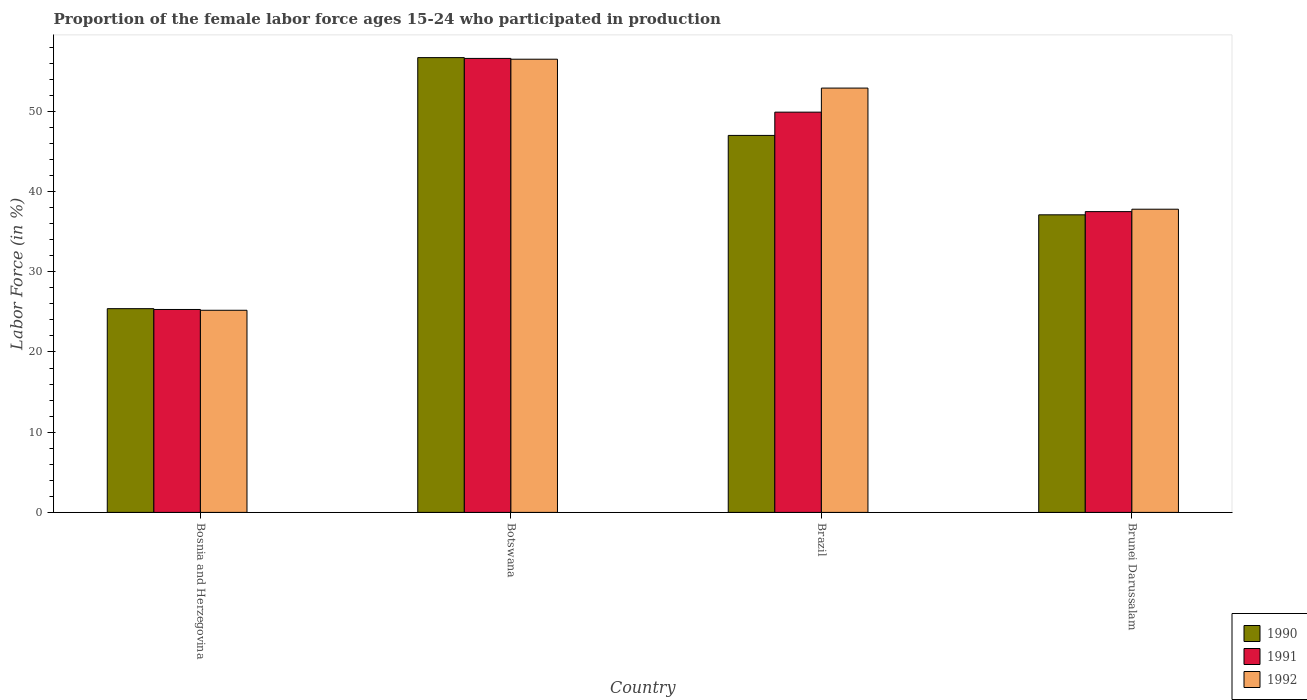How many different coloured bars are there?
Give a very brief answer. 3. How many groups of bars are there?
Keep it short and to the point. 4. Are the number of bars per tick equal to the number of legend labels?
Your answer should be very brief. Yes. Are the number of bars on each tick of the X-axis equal?
Offer a very short reply. Yes. How many bars are there on the 4th tick from the left?
Your answer should be very brief. 3. What is the label of the 1st group of bars from the left?
Keep it short and to the point. Bosnia and Herzegovina. What is the proportion of the female labor force who participated in production in 1990 in Brunei Darussalam?
Provide a short and direct response. 37.1. Across all countries, what is the maximum proportion of the female labor force who participated in production in 1992?
Provide a short and direct response. 56.5. Across all countries, what is the minimum proportion of the female labor force who participated in production in 1990?
Keep it short and to the point. 25.4. In which country was the proportion of the female labor force who participated in production in 1992 maximum?
Offer a very short reply. Botswana. In which country was the proportion of the female labor force who participated in production in 1992 minimum?
Give a very brief answer. Bosnia and Herzegovina. What is the total proportion of the female labor force who participated in production in 1990 in the graph?
Keep it short and to the point. 166.2. What is the difference between the proportion of the female labor force who participated in production in 1990 in Bosnia and Herzegovina and that in Brazil?
Provide a succinct answer. -21.6. What is the difference between the proportion of the female labor force who participated in production in 1991 in Bosnia and Herzegovina and the proportion of the female labor force who participated in production in 1992 in Brazil?
Your response must be concise. -27.6. What is the average proportion of the female labor force who participated in production in 1991 per country?
Ensure brevity in your answer.  42.32. What is the difference between the proportion of the female labor force who participated in production of/in 1990 and proportion of the female labor force who participated in production of/in 1992 in Bosnia and Herzegovina?
Offer a very short reply. 0.2. What is the ratio of the proportion of the female labor force who participated in production in 1990 in Brazil to that in Brunei Darussalam?
Offer a terse response. 1.27. Is the difference between the proportion of the female labor force who participated in production in 1990 in Botswana and Brunei Darussalam greater than the difference between the proportion of the female labor force who participated in production in 1992 in Botswana and Brunei Darussalam?
Your answer should be very brief. Yes. What is the difference between the highest and the second highest proportion of the female labor force who participated in production in 1992?
Offer a terse response. 3.6. What is the difference between the highest and the lowest proportion of the female labor force who participated in production in 1992?
Your answer should be compact. 31.3. What does the 2nd bar from the left in Bosnia and Herzegovina represents?
Ensure brevity in your answer.  1991. What does the 3rd bar from the right in Brazil represents?
Offer a very short reply. 1990. Are all the bars in the graph horizontal?
Give a very brief answer. No. How many countries are there in the graph?
Keep it short and to the point. 4. Does the graph contain any zero values?
Keep it short and to the point. No. How many legend labels are there?
Provide a short and direct response. 3. How are the legend labels stacked?
Provide a succinct answer. Vertical. What is the title of the graph?
Offer a very short reply. Proportion of the female labor force ages 15-24 who participated in production. Does "1991" appear as one of the legend labels in the graph?
Provide a short and direct response. Yes. What is the label or title of the Y-axis?
Keep it short and to the point. Labor Force (in %). What is the Labor Force (in %) in 1990 in Bosnia and Herzegovina?
Offer a terse response. 25.4. What is the Labor Force (in %) of 1991 in Bosnia and Herzegovina?
Give a very brief answer. 25.3. What is the Labor Force (in %) in 1992 in Bosnia and Herzegovina?
Your answer should be very brief. 25.2. What is the Labor Force (in %) of 1990 in Botswana?
Provide a succinct answer. 56.7. What is the Labor Force (in %) of 1991 in Botswana?
Offer a very short reply. 56.6. What is the Labor Force (in %) in 1992 in Botswana?
Keep it short and to the point. 56.5. What is the Labor Force (in %) of 1990 in Brazil?
Give a very brief answer. 47. What is the Labor Force (in %) in 1991 in Brazil?
Your answer should be very brief. 49.9. What is the Labor Force (in %) of 1992 in Brazil?
Give a very brief answer. 52.9. What is the Labor Force (in %) in 1990 in Brunei Darussalam?
Your response must be concise. 37.1. What is the Labor Force (in %) of 1991 in Brunei Darussalam?
Keep it short and to the point. 37.5. What is the Labor Force (in %) in 1992 in Brunei Darussalam?
Offer a very short reply. 37.8. Across all countries, what is the maximum Labor Force (in %) in 1990?
Provide a short and direct response. 56.7. Across all countries, what is the maximum Labor Force (in %) of 1991?
Give a very brief answer. 56.6. Across all countries, what is the maximum Labor Force (in %) in 1992?
Your response must be concise. 56.5. Across all countries, what is the minimum Labor Force (in %) of 1990?
Give a very brief answer. 25.4. Across all countries, what is the minimum Labor Force (in %) in 1991?
Provide a succinct answer. 25.3. Across all countries, what is the minimum Labor Force (in %) of 1992?
Your answer should be very brief. 25.2. What is the total Labor Force (in %) in 1990 in the graph?
Your answer should be very brief. 166.2. What is the total Labor Force (in %) in 1991 in the graph?
Your answer should be compact. 169.3. What is the total Labor Force (in %) of 1992 in the graph?
Your answer should be very brief. 172.4. What is the difference between the Labor Force (in %) of 1990 in Bosnia and Herzegovina and that in Botswana?
Offer a terse response. -31.3. What is the difference between the Labor Force (in %) of 1991 in Bosnia and Herzegovina and that in Botswana?
Ensure brevity in your answer.  -31.3. What is the difference between the Labor Force (in %) in 1992 in Bosnia and Herzegovina and that in Botswana?
Provide a short and direct response. -31.3. What is the difference between the Labor Force (in %) of 1990 in Bosnia and Herzegovina and that in Brazil?
Your answer should be compact. -21.6. What is the difference between the Labor Force (in %) of 1991 in Bosnia and Herzegovina and that in Brazil?
Your response must be concise. -24.6. What is the difference between the Labor Force (in %) of 1992 in Bosnia and Herzegovina and that in Brazil?
Make the answer very short. -27.7. What is the difference between the Labor Force (in %) of 1990 in Botswana and that in Brazil?
Your answer should be very brief. 9.7. What is the difference between the Labor Force (in %) of 1992 in Botswana and that in Brazil?
Ensure brevity in your answer.  3.6. What is the difference between the Labor Force (in %) in 1990 in Botswana and that in Brunei Darussalam?
Provide a short and direct response. 19.6. What is the difference between the Labor Force (in %) in 1991 in Botswana and that in Brunei Darussalam?
Keep it short and to the point. 19.1. What is the difference between the Labor Force (in %) in 1990 in Brazil and that in Brunei Darussalam?
Make the answer very short. 9.9. What is the difference between the Labor Force (in %) of 1991 in Brazil and that in Brunei Darussalam?
Provide a succinct answer. 12.4. What is the difference between the Labor Force (in %) in 1992 in Brazil and that in Brunei Darussalam?
Ensure brevity in your answer.  15.1. What is the difference between the Labor Force (in %) in 1990 in Bosnia and Herzegovina and the Labor Force (in %) in 1991 in Botswana?
Give a very brief answer. -31.2. What is the difference between the Labor Force (in %) in 1990 in Bosnia and Herzegovina and the Labor Force (in %) in 1992 in Botswana?
Ensure brevity in your answer.  -31.1. What is the difference between the Labor Force (in %) of 1991 in Bosnia and Herzegovina and the Labor Force (in %) of 1992 in Botswana?
Offer a very short reply. -31.2. What is the difference between the Labor Force (in %) of 1990 in Bosnia and Herzegovina and the Labor Force (in %) of 1991 in Brazil?
Make the answer very short. -24.5. What is the difference between the Labor Force (in %) of 1990 in Bosnia and Herzegovina and the Labor Force (in %) of 1992 in Brazil?
Your answer should be very brief. -27.5. What is the difference between the Labor Force (in %) of 1991 in Bosnia and Herzegovina and the Labor Force (in %) of 1992 in Brazil?
Make the answer very short. -27.6. What is the difference between the Labor Force (in %) of 1990 in Bosnia and Herzegovina and the Labor Force (in %) of 1991 in Brunei Darussalam?
Your answer should be very brief. -12.1. What is the difference between the Labor Force (in %) of 1990 in Bosnia and Herzegovina and the Labor Force (in %) of 1992 in Brunei Darussalam?
Offer a terse response. -12.4. What is the difference between the Labor Force (in %) in 1991 in Bosnia and Herzegovina and the Labor Force (in %) in 1992 in Brunei Darussalam?
Ensure brevity in your answer.  -12.5. What is the difference between the Labor Force (in %) of 1990 in Botswana and the Labor Force (in %) of 1991 in Brazil?
Offer a very short reply. 6.8. What is the difference between the Labor Force (in %) in 1990 in Botswana and the Labor Force (in %) in 1991 in Brunei Darussalam?
Offer a very short reply. 19.2. What is the difference between the Labor Force (in %) of 1991 in Botswana and the Labor Force (in %) of 1992 in Brunei Darussalam?
Provide a succinct answer. 18.8. What is the difference between the Labor Force (in %) of 1990 in Brazil and the Labor Force (in %) of 1991 in Brunei Darussalam?
Your response must be concise. 9.5. What is the average Labor Force (in %) of 1990 per country?
Provide a short and direct response. 41.55. What is the average Labor Force (in %) in 1991 per country?
Provide a short and direct response. 42.33. What is the average Labor Force (in %) of 1992 per country?
Keep it short and to the point. 43.1. What is the difference between the Labor Force (in %) in 1990 and Labor Force (in %) in 1991 in Bosnia and Herzegovina?
Your response must be concise. 0.1. What is the difference between the Labor Force (in %) of 1990 and Labor Force (in %) of 1991 in Botswana?
Provide a succinct answer. 0.1. What is the difference between the Labor Force (in %) in 1990 and Labor Force (in %) in 1992 in Botswana?
Make the answer very short. 0.2. What is the difference between the Labor Force (in %) in 1991 and Labor Force (in %) in 1992 in Botswana?
Give a very brief answer. 0.1. What is the difference between the Labor Force (in %) in 1990 and Labor Force (in %) in 1992 in Brazil?
Ensure brevity in your answer.  -5.9. What is the difference between the Labor Force (in %) of 1990 and Labor Force (in %) of 1991 in Brunei Darussalam?
Make the answer very short. -0.4. What is the difference between the Labor Force (in %) of 1990 and Labor Force (in %) of 1992 in Brunei Darussalam?
Offer a terse response. -0.7. What is the difference between the Labor Force (in %) in 1991 and Labor Force (in %) in 1992 in Brunei Darussalam?
Your answer should be compact. -0.3. What is the ratio of the Labor Force (in %) of 1990 in Bosnia and Herzegovina to that in Botswana?
Give a very brief answer. 0.45. What is the ratio of the Labor Force (in %) of 1991 in Bosnia and Herzegovina to that in Botswana?
Ensure brevity in your answer.  0.45. What is the ratio of the Labor Force (in %) in 1992 in Bosnia and Herzegovina to that in Botswana?
Provide a short and direct response. 0.45. What is the ratio of the Labor Force (in %) of 1990 in Bosnia and Herzegovina to that in Brazil?
Ensure brevity in your answer.  0.54. What is the ratio of the Labor Force (in %) of 1991 in Bosnia and Herzegovina to that in Brazil?
Give a very brief answer. 0.51. What is the ratio of the Labor Force (in %) of 1992 in Bosnia and Herzegovina to that in Brazil?
Make the answer very short. 0.48. What is the ratio of the Labor Force (in %) of 1990 in Bosnia and Herzegovina to that in Brunei Darussalam?
Keep it short and to the point. 0.68. What is the ratio of the Labor Force (in %) in 1991 in Bosnia and Herzegovina to that in Brunei Darussalam?
Give a very brief answer. 0.67. What is the ratio of the Labor Force (in %) in 1990 in Botswana to that in Brazil?
Your answer should be compact. 1.21. What is the ratio of the Labor Force (in %) of 1991 in Botswana to that in Brazil?
Give a very brief answer. 1.13. What is the ratio of the Labor Force (in %) of 1992 in Botswana to that in Brazil?
Ensure brevity in your answer.  1.07. What is the ratio of the Labor Force (in %) of 1990 in Botswana to that in Brunei Darussalam?
Offer a very short reply. 1.53. What is the ratio of the Labor Force (in %) of 1991 in Botswana to that in Brunei Darussalam?
Your response must be concise. 1.51. What is the ratio of the Labor Force (in %) of 1992 in Botswana to that in Brunei Darussalam?
Your answer should be compact. 1.49. What is the ratio of the Labor Force (in %) of 1990 in Brazil to that in Brunei Darussalam?
Provide a succinct answer. 1.27. What is the ratio of the Labor Force (in %) of 1991 in Brazil to that in Brunei Darussalam?
Your answer should be very brief. 1.33. What is the ratio of the Labor Force (in %) of 1992 in Brazil to that in Brunei Darussalam?
Give a very brief answer. 1.4. What is the difference between the highest and the second highest Labor Force (in %) of 1991?
Give a very brief answer. 6.7. What is the difference between the highest and the lowest Labor Force (in %) of 1990?
Provide a succinct answer. 31.3. What is the difference between the highest and the lowest Labor Force (in %) in 1991?
Make the answer very short. 31.3. What is the difference between the highest and the lowest Labor Force (in %) of 1992?
Your answer should be very brief. 31.3. 